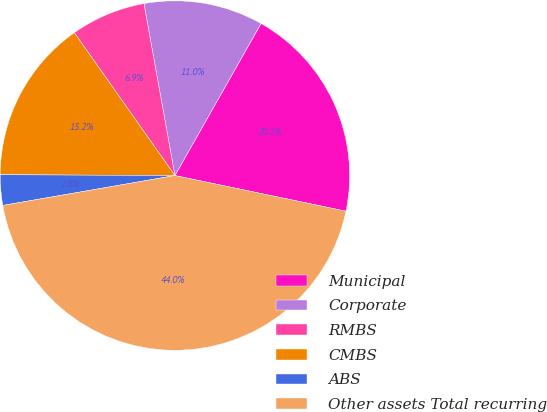Convert chart. <chart><loc_0><loc_0><loc_500><loc_500><pie_chart><fcel>Municipal<fcel>Corporate<fcel>RMBS<fcel>CMBS<fcel>ABS<fcel>Other assets Total recurring<nl><fcel>20.07%<fcel>11.04%<fcel>6.93%<fcel>15.16%<fcel>2.81%<fcel>43.99%<nl></chart> 